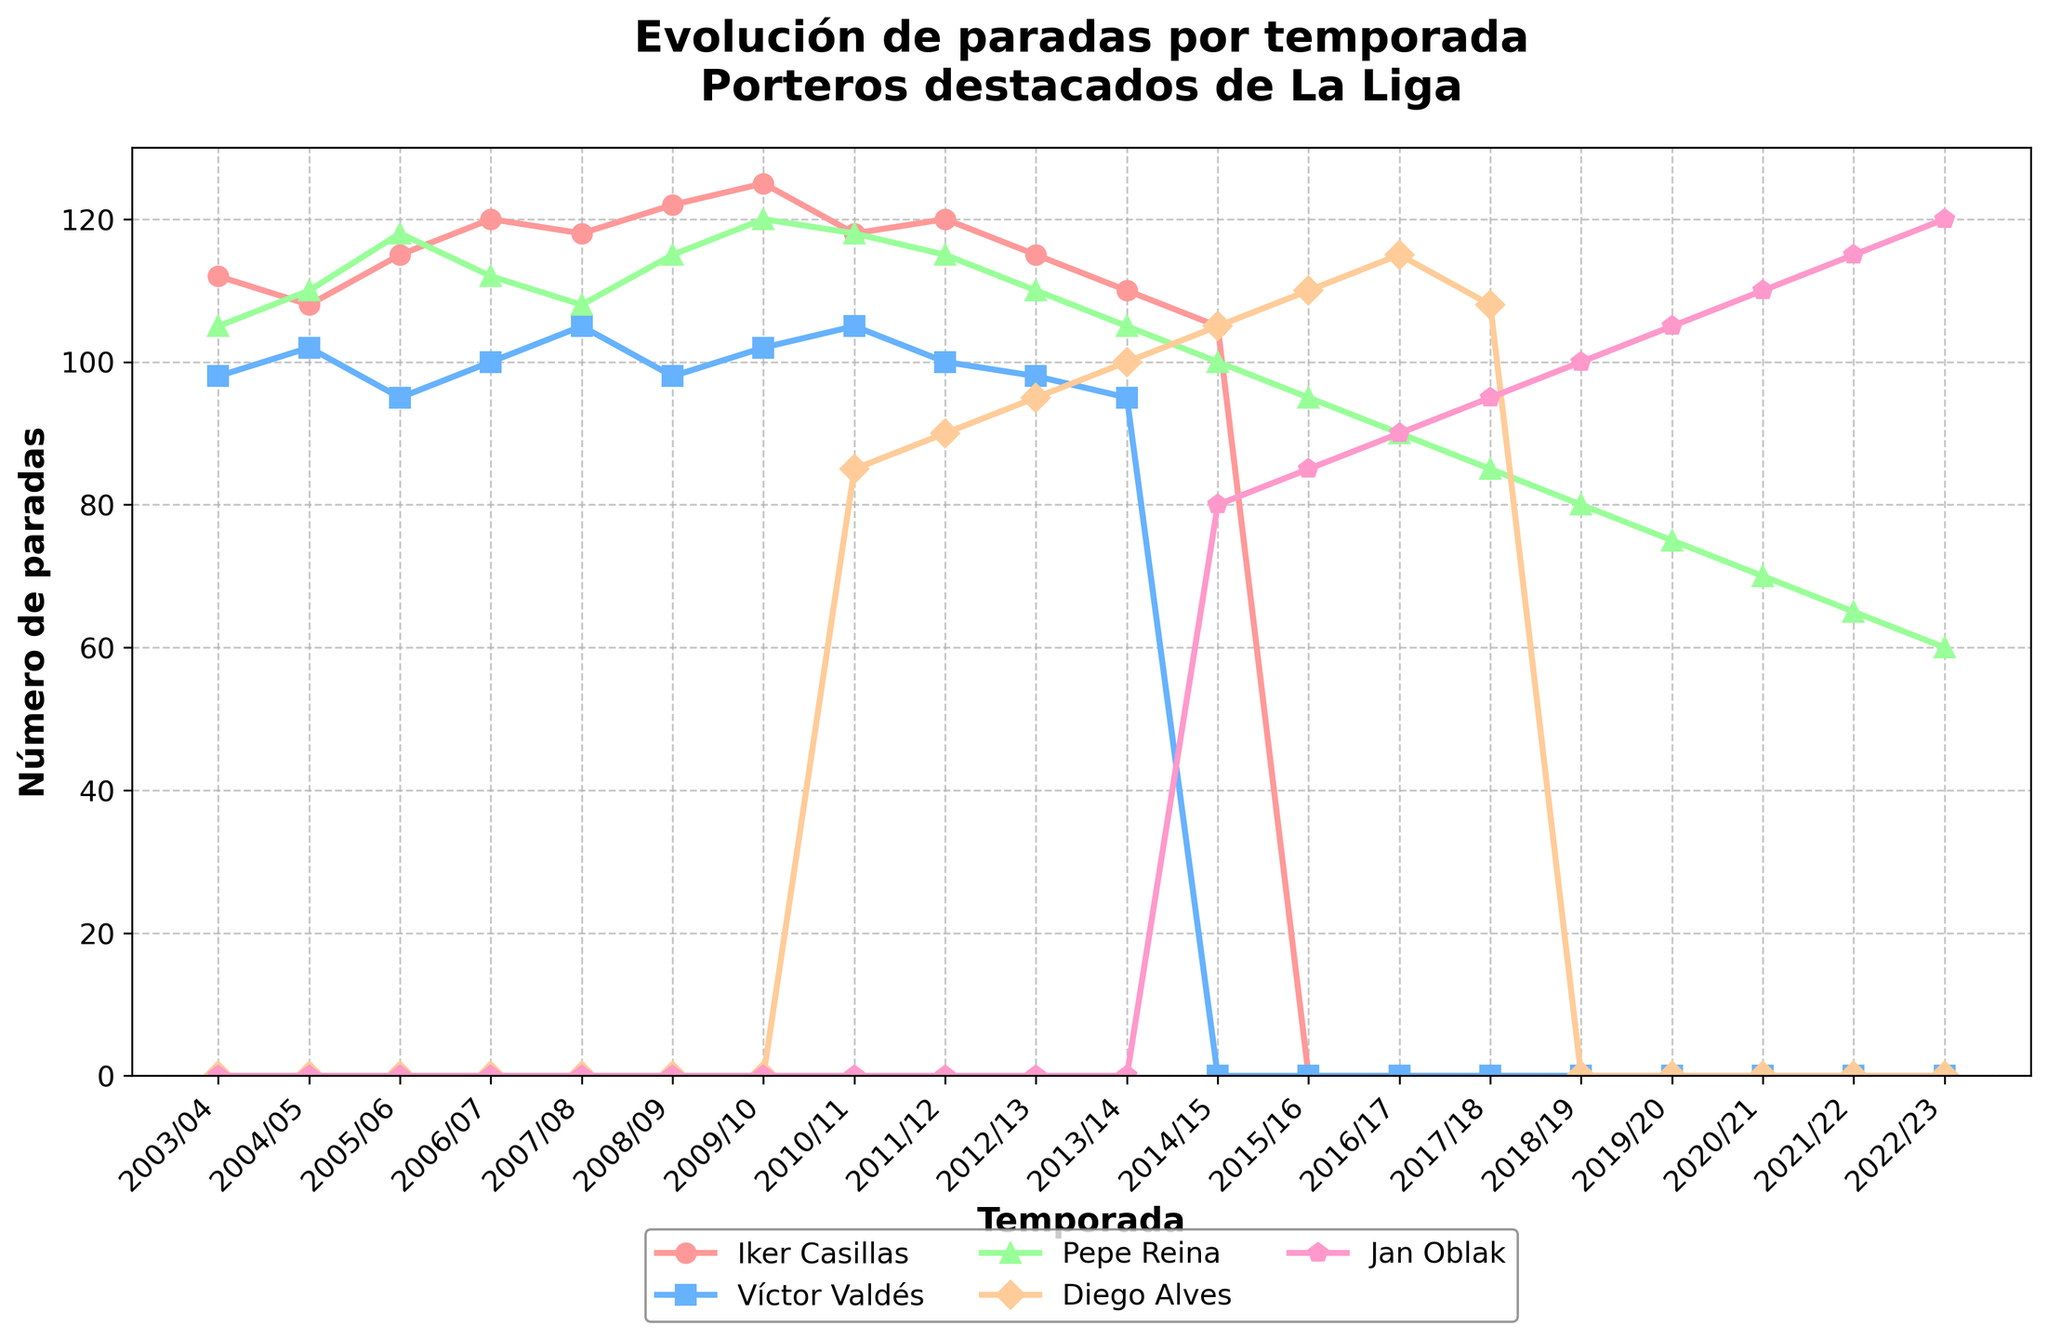What's the highest number of saves made by Iker Casillas in a single season? To find this, look for the peak point in Iker Casillas's line in the chart. The highest point corresponds to the 2009/10 season where his saves reached 125.
Answer: 125 In which season did Jan Oblak start appearing in the data for saves? Identify the point where Jan Oblak's saves data first appears in the chart. It starts from the 2014/15 season.
Answer: 2014/15 How many more saves did Pepe Reina have compared to Víctor Valdés in the 2005/06 season? Find the respective values for Pepe Reina and Víctor Valdés in the 2005/06 season. Pepe Reina had 118 saves and Víctor Valdés had 95. The difference is 118 - 95 = 23.
Answer: 23 What is the average number of saves per season for Diego Alves between 2010/11 and 2017/18? Calculate the total saves by Diego Alves from 2010/11 to 2017/18 (85 + 90 + 95 + 100 + 105 + 110 + 115 + 108). Then divide by the number of seasons (8): (85 + 90 + 95 + 100 + 105 + 110 + 115 + 108) / 8 = 101.
Answer: 101 Which goalkeeper had the lowest number of saves in the 2022/23 season? Look at the data points for the 2022/23 season. Pepe Reina had the lowest with 60 saves.
Answer: Pepe Reina Did Víctor Valdés ever have more saves in a season than Iker Casillas? Compare their values across all seasons where both played. In none of the seasons did Víctor Valdés have more saves than Iker Casillas.
Answer: No What is the difference in the number of saves between the peak season of Iker Casillas and Jan Oblak? Find the peak seasons and corresponding saves: Iker Casillas (2009/10 with 125 saves) and Jan Oblak (2022/23 with 120 saves). The difference is 125 - 120 = 5.
Answer: 5 During the 2014/15 season, compare the saves of Diego Alves and Jan Oblak. Who had more and by how much? In the 2014/15 season, Diego Alves made 105 saves and Jan Oblak made 80 saves. The difference is 105 - 80 = 25. Diego Alves had more saves.
Answer: Diego Alves by 25 Identify the goalkeepers who have data available for all 20 seasons. Examine the data for continuity across all seasons. Only Iker Casillas and Víctor Valdés have data for all the seasons they played (missing seasons are because they stopped playing, not due to incomplete data).
Answer: Iker Casillas, Víctor Valdés How many saves did Pepe Reina make in total from 2003/04 to 2022/23? Sum all the saves made by Pepe Reina from 2003/04 to 2022/23 (105 + 110 + 118 + 112 + 108 + 115 + 120 + 118 + 115 + 110 + 105 + 100 + 95 + 90 + 85 + 80 + 75 + 70 + 65 + 60): 1836.
Answer: 1836 